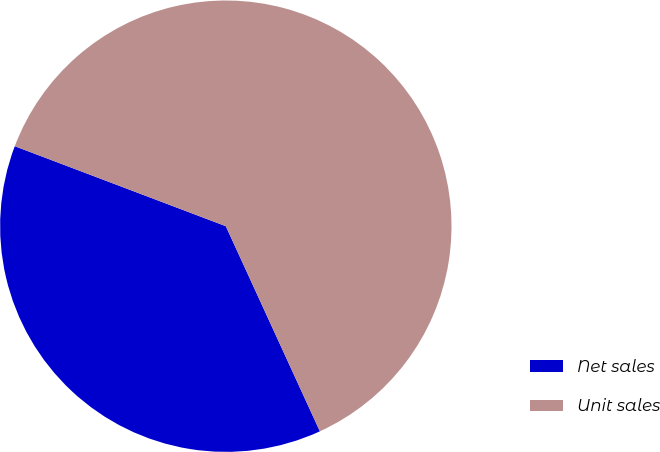<chart> <loc_0><loc_0><loc_500><loc_500><pie_chart><fcel>Net sales<fcel>Unit sales<nl><fcel>37.61%<fcel>62.39%<nl></chart> 